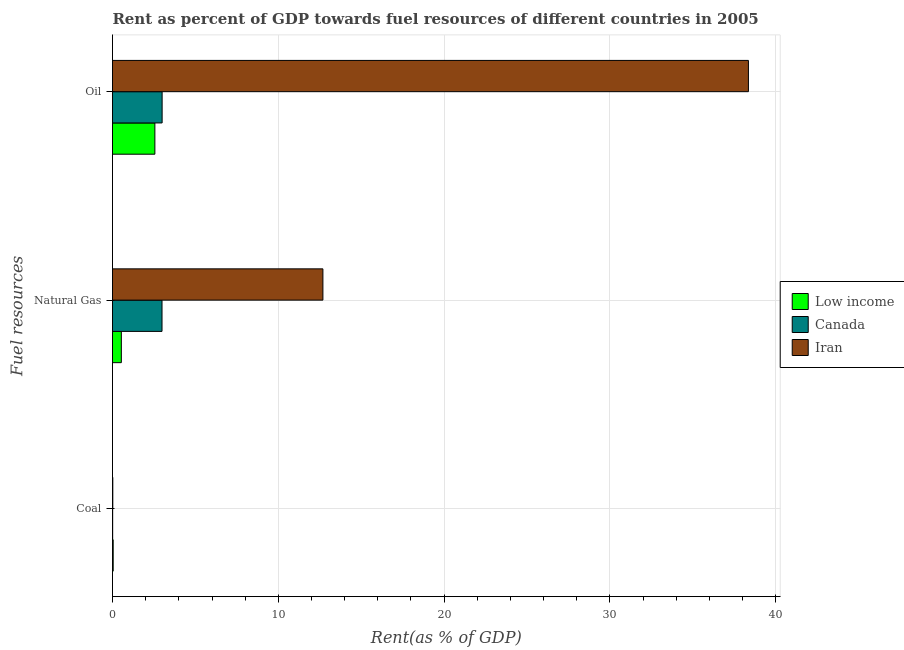Are the number of bars per tick equal to the number of legend labels?
Keep it short and to the point. Yes. What is the label of the 3rd group of bars from the top?
Offer a very short reply. Coal. What is the rent towards oil in Low income?
Keep it short and to the point. 2.56. Across all countries, what is the maximum rent towards natural gas?
Your answer should be very brief. 12.69. Across all countries, what is the minimum rent towards natural gas?
Make the answer very short. 0.53. In which country was the rent towards oil maximum?
Provide a succinct answer. Iran. In which country was the rent towards oil minimum?
Your answer should be very brief. Low income. What is the total rent towards natural gas in the graph?
Your answer should be very brief. 16.21. What is the difference between the rent towards oil in Canada and that in Iran?
Keep it short and to the point. -35.36. What is the difference between the rent towards oil in Low income and the rent towards natural gas in Canada?
Offer a very short reply. -0.43. What is the average rent towards natural gas per country?
Keep it short and to the point. 5.4. What is the difference between the rent towards coal and rent towards oil in Iran?
Provide a short and direct response. -38.33. What is the ratio of the rent towards natural gas in Iran to that in Canada?
Provide a succinct answer. 4.25. Is the rent towards natural gas in Low income less than that in Iran?
Make the answer very short. Yes. Is the difference between the rent towards oil in Iran and Low income greater than the difference between the rent towards coal in Iran and Low income?
Make the answer very short. Yes. What is the difference between the highest and the second highest rent towards coal?
Make the answer very short. 0.02. What is the difference between the highest and the lowest rent towards natural gas?
Offer a terse response. 12.16. In how many countries, is the rent towards natural gas greater than the average rent towards natural gas taken over all countries?
Provide a succinct answer. 1. Is the sum of the rent towards oil in Low income and Canada greater than the maximum rent towards coal across all countries?
Provide a short and direct response. Yes. What does the 1st bar from the top in Coal represents?
Provide a succinct answer. Iran. What does the 3rd bar from the bottom in Natural Gas represents?
Provide a succinct answer. Iran. How many bars are there?
Offer a terse response. 9. Are all the bars in the graph horizontal?
Make the answer very short. Yes. What is the difference between two consecutive major ticks on the X-axis?
Your answer should be very brief. 10. Does the graph contain any zero values?
Make the answer very short. No. How many legend labels are there?
Ensure brevity in your answer.  3. How are the legend labels stacked?
Your answer should be compact. Vertical. What is the title of the graph?
Provide a short and direct response. Rent as percent of GDP towards fuel resources of different countries in 2005. Does "Marshall Islands" appear as one of the legend labels in the graph?
Ensure brevity in your answer.  No. What is the label or title of the X-axis?
Give a very brief answer. Rent(as % of GDP). What is the label or title of the Y-axis?
Give a very brief answer. Fuel resources. What is the Rent(as % of GDP) in Low income in Coal?
Make the answer very short. 0.04. What is the Rent(as % of GDP) of Canada in Coal?
Your response must be concise. 0.01. What is the Rent(as % of GDP) of Iran in Coal?
Ensure brevity in your answer.  0.02. What is the Rent(as % of GDP) in Low income in Natural Gas?
Your answer should be very brief. 0.53. What is the Rent(as % of GDP) of Canada in Natural Gas?
Keep it short and to the point. 2.99. What is the Rent(as % of GDP) in Iran in Natural Gas?
Provide a short and direct response. 12.69. What is the Rent(as % of GDP) in Low income in Oil?
Give a very brief answer. 2.56. What is the Rent(as % of GDP) of Canada in Oil?
Offer a very short reply. 2.99. What is the Rent(as % of GDP) in Iran in Oil?
Give a very brief answer. 38.35. Across all Fuel resources, what is the maximum Rent(as % of GDP) in Low income?
Offer a terse response. 2.56. Across all Fuel resources, what is the maximum Rent(as % of GDP) of Canada?
Keep it short and to the point. 2.99. Across all Fuel resources, what is the maximum Rent(as % of GDP) of Iran?
Provide a short and direct response. 38.35. Across all Fuel resources, what is the minimum Rent(as % of GDP) of Low income?
Offer a very short reply. 0.04. Across all Fuel resources, what is the minimum Rent(as % of GDP) in Canada?
Keep it short and to the point. 0.01. Across all Fuel resources, what is the minimum Rent(as % of GDP) of Iran?
Give a very brief answer. 0.02. What is the total Rent(as % of GDP) in Low income in the graph?
Give a very brief answer. 3.13. What is the total Rent(as % of GDP) in Canada in the graph?
Provide a short and direct response. 5.99. What is the total Rent(as % of GDP) in Iran in the graph?
Give a very brief answer. 51.06. What is the difference between the Rent(as % of GDP) of Low income in Coal and that in Natural Gas?
Give a very brief answer. -0.49. What is the difference between the Rent(as % of GDP) of Canada in Coal and that in Natural Gas?
Your response must be concise. -2.98. What is the difference between the Rent(as % of GDP) in Iran in Coal and that in Natural Gas?
Your response must be concise. -12.67. What is the difference between the Rent(as % of GDP) in Low income in Coal and that in Oil?
Your answer should be compact. -2.51. What is the difference between the Rent(as % of GDP) in Canada in Coal and that in Oil?
Offer a terse response. -2.98. What is the difference between the Rent(as % of GDP) in Iran in Coal and that in Oil?
Your response must be concise. -38.33. What is the difference between the Rent(as % of GDP) in Low income in Natural Gas and that in Oil?
Provide a short and direct response. -2.02. What is the difference between the Rent(as % of GDP) in Canada in Natural Gas and that in Oil?
Give a very brief answer. -0.01. What is the difference between the Rent(as % of GDP) of Iran in Natural Gas and that in Oil?
Keep it short and to the point. -25.66. What is the difference between the Rent(as % of GDP) of Low income in Coal and the Rent(as % of GDP) of Canada in Natural Gas?
Your answer should be compact. -2.94. What is the difference between the Rent(as % of GDP) of Low income in Coal and the Rent(as % of GDP) of Iran in Natural Gas?
Your response must be concise. -12.65. What is the difference between the Rent(as % of GDP) of Canada in Coal and the Rent(as % of GDP) of Iran in Natural Gas?
Provide a short and direct response. -12.68. What is the difference between the Rent(as % of GDP) of Low income in Coal and the Rent(as % of GDP) of Canada in Oil?
Your answer should be compact. -2.95. What is the difference between the Rent(as % of GDP) of Low income in Coal and the Rent(as % of GDP) of Iran in Oil?
Give a very brief answer. -38.31. What is the difference between the Rent(as % of GDP) of Canada in Coal and the Rent(as % of GDP) of Iran in Oil?
Your answer should be compact. -38.34. What is the difference between the Rent(as % of GDP) in Low income in Natural Gas and the Rent(as % of GDP) in Canada in Oil?
Make the answer very short. -2.46. What is the difference between the Rent(as % of GDP) in Low income in Natural Gas and the Rent(as % of GDP) in Iran in Oil?
Provide a short and direct response. -37.82. What is the difference between the Rent(as % of GDP) of Canada in Natural Gas and the Rent(as % of GDP) of Iran in Oil?
Your answer should be compact. -35.36. What is the average Rent(as % of GDP) of Low income per Fuel resources?
Give a very brief answer. 1.04. What is the average Rent(as % of GDP) of Canada per Fuel resources?
Offer a very short reply. 2. What is the average Rent(as % of GDP) of Iran per Fuel resources?
Make the answer very short. 17.02. What is the difference between the Rent(as % of GDP) of Low income and Rent(as % of GDP) of Canada in Coal?
Ensure brevity in your answer.  0.03. What is the difference between the Rent(as % of GDP) in Low income and Rent(as % of GDP) in Iran in Coal?
Provide a succinct answer. 0.02. What is the difference between the Rent(as % of GDP) in Canada and Rent(as % of GDP) in Iran in Coal?
Keep it short and to the point. -0.01. What is the difference between the Rent(as % of GDP) of Low income and Rent(as % of GDP) of Canada in Natural Gas?
Give a very brief answer. -2.45. What is the difference between the Rent(as % of GDP) of Low income and Rent(as % of GDP) of Iran in Natural Gas?
Your answer should be very brief. -12.16. What is the difference between the Rent(as % of GDP) in Canada and Rent(as % of GDP) in Iran in Natural Gas?
Offer a very short reply. -9.7. What is the difference between the Rent(as % of GDP) in Low income and Rent(as % of GDP) in Canada in Oil?
Provide a short and direct response. -0.44. What is the difference between the Rent(as % of GDP) in Low income and Rent(as % of GDP) in Iran in Oil?
Give a very brief answer. -35.79. What is the difference between the Rent(as % of GDP) of Canada and Rent(as % of GDP) of Iran in Oil?
Offer a very short reply. -35.36. What is the ratio of the Rent(as % of GDP) in Low income in Coal to that in Natural Gas?
Offer a very short reply. 0.08. What is the ratio of the Rent(as % of GDP) of Canada in Coal to that in Natural Gas?
Ensure brevity in your answer.  0. What is the ratio of the Rent(as % of GDP) in Iran in Coal to that in Natural Gas?
Your answer should be compact. 0. What is the ratio of the Rent(as % of GDP) in Low income in Coal to that in Oil?
Keep it short and to the point. 0.02. What is the ratio of the Rent(as % of GDP) of Canada in Coal to that in Oil?
Your answer should be very brief. 0. What is the ratio of the Rent(as % of GDP) in Low income in Natural Gas to that in Oil?
Make the answer very short. 0.21. What is the ratio of the Rent(as % of GDP) of Iran in Natural Gas to that in Oil?
Provide a short and direct response. 0.33. What is the difference between the highest and the second highest Rent(as % of GDP) in Low income?
Make the answer very short. 2.02. What is the difference between the highest and the second highest Rent(as % of GDP) in Canada?
Offer a very short reply. 0.01. What is the difference between the highest and the second highest Rent(as % of GDP) in Iran?
Provide a short and direct response. 25.66. What is the difference between the highest and the lowest Rent(as % of GDP) of Low income?
Provide a short and direct response. 2.51. What is the difference between the highest and the lowest Rent(as % of GDP) of Canada?
Offer a very short reply. 2.98. What is the difference between the highest and the lowest Rent(as % of GDP) in Iran?
Provide a succinct answer. 38.33. 